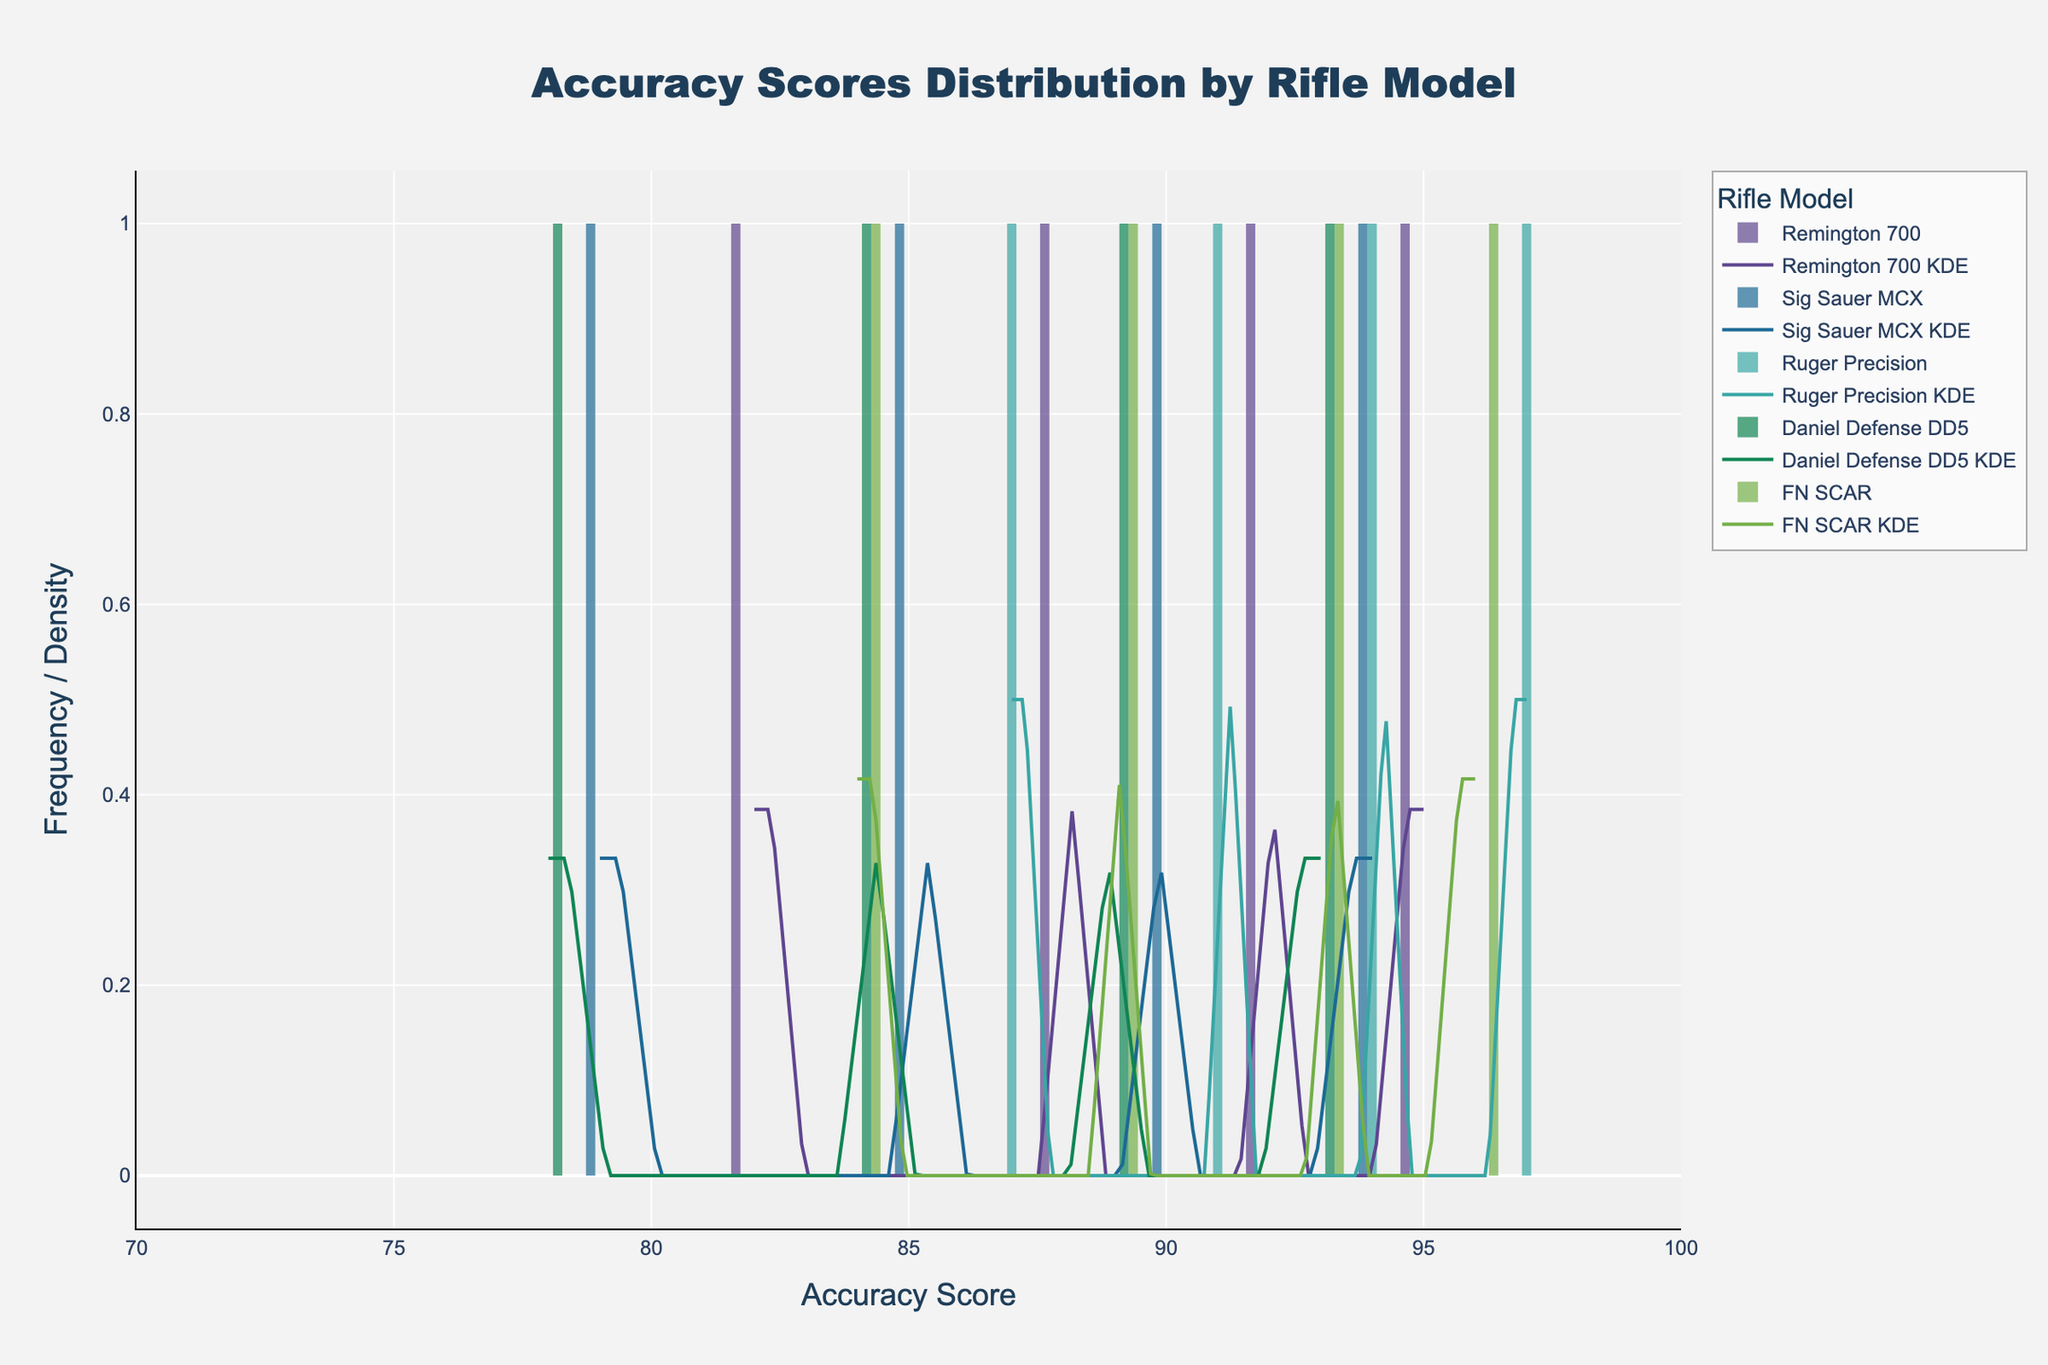What is the title of the figure? The title is usually found at the top of the figure. It summarizes the main focus or topic of the plot.
Answer: "Accuracy Scores Distribution by Rifle Model" How many rifle models are represented in the figure? Each rifle model is represented by a unique color in the histogram and KDE curves. Counting the different colors gives the number of models.
Answer: 5 models Which rifle model has the highest peak in its KDE curve? The peak of a KDE curve represents the score with the highest density. By visually comparing the height of the KDE peaks, we can identify the tallest one.
Answer: Ruger Precision What is the range of accuracy scores shown on the x-axis? The range can be determined by looking at the minimum and maximum values marked on the x-axis.
Answer: 70 to 100 Which rifle model shows the most overlap in accuracy scores with the Daniel Defense DD5 model? To determine the overlap, compare the histogram bars and KDE curves of each model with the Daniel Defense DD5 model. Look for the model whose distribution most aligns with the Daniel Defense DD5's.
Answer: Sig Sauer MCX What is the average accuracy score for the Remington 700 model? To find the average, sum the accuracy scores of the Remington 700 model and divide by the number of scores: (95 + 92 + 88 + 82) / 4.
Answer: 89.25 Which rifle models have their highest accuracy score at 50 meters? Look at each model's data or KDE peaks corresponding to 50 meters to identify the highest scores. Verify by checking the histogram bars.
Answer: Remington 700, Sig Sauer MCX, Ruger Precision, Daniel Defense DD5, FN SCAR Between 80 and 90 accuracy scores, which rifle model shows the highest frequency? Compare the height of histogram bars that fall within the 80-90 accuracy score range. Identify which model has the tallest bar(s) in this section.
Answer: Remington 700 What is the difference in average accuracy scores between the Ruger Precision and FN SCAR models? First, calculate the averages: Ruger Precision (97 + 94 + 91 + 87) / 4 = 92.25, FN SCAR (96 + 93 + 89 + 84) / 4 = 90.5. Then, subtract the averages to find the difference.
Answer: 1.75 Which model has the broadest distribution of accuracy scores? The broadest distribution can be identified by the width of the KDE curve. The model with the most spread-out curve has the broadest distribution.
Answer: Daniel Defense DD5 